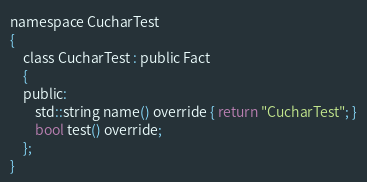<code> <loc_0><loc_0><loc_500><loc_500><_C_>namespace CucharTest
{
	class CucharTest : public Fact
	{
	public:
		std::string name() override { return "CucharTest"; }
		bool test() override;
	};
}</code> 